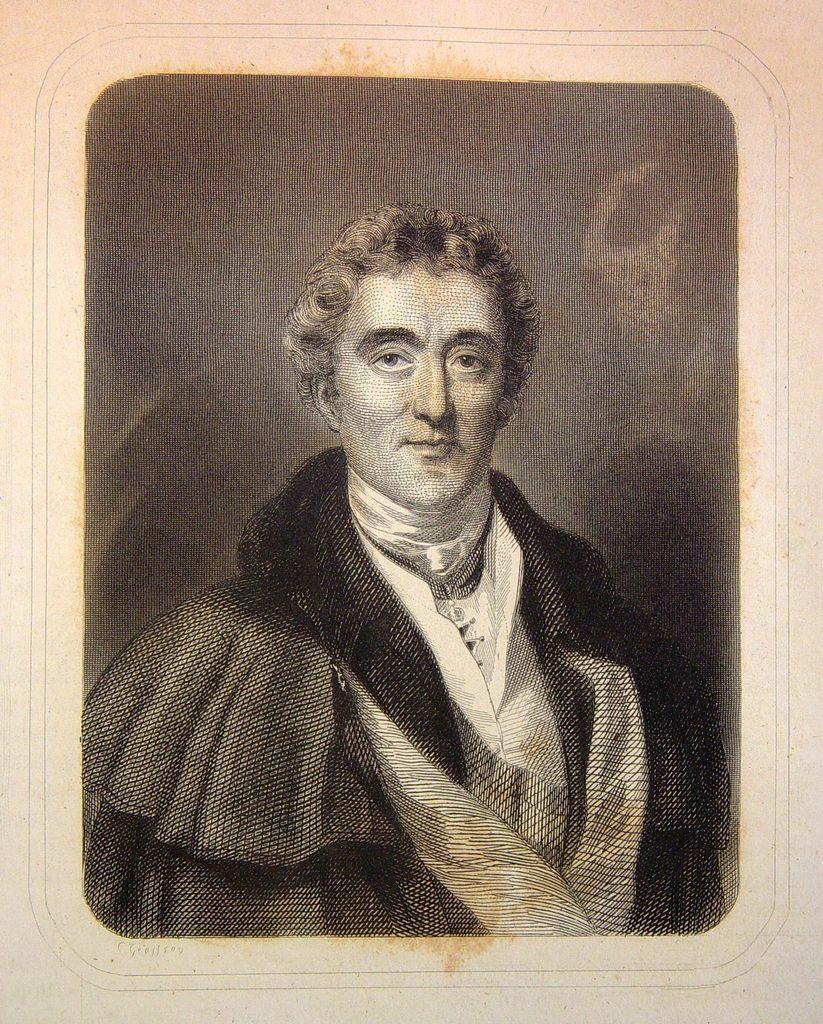How would you summarize this image in a sentence or two? In this picture I can see a man. 